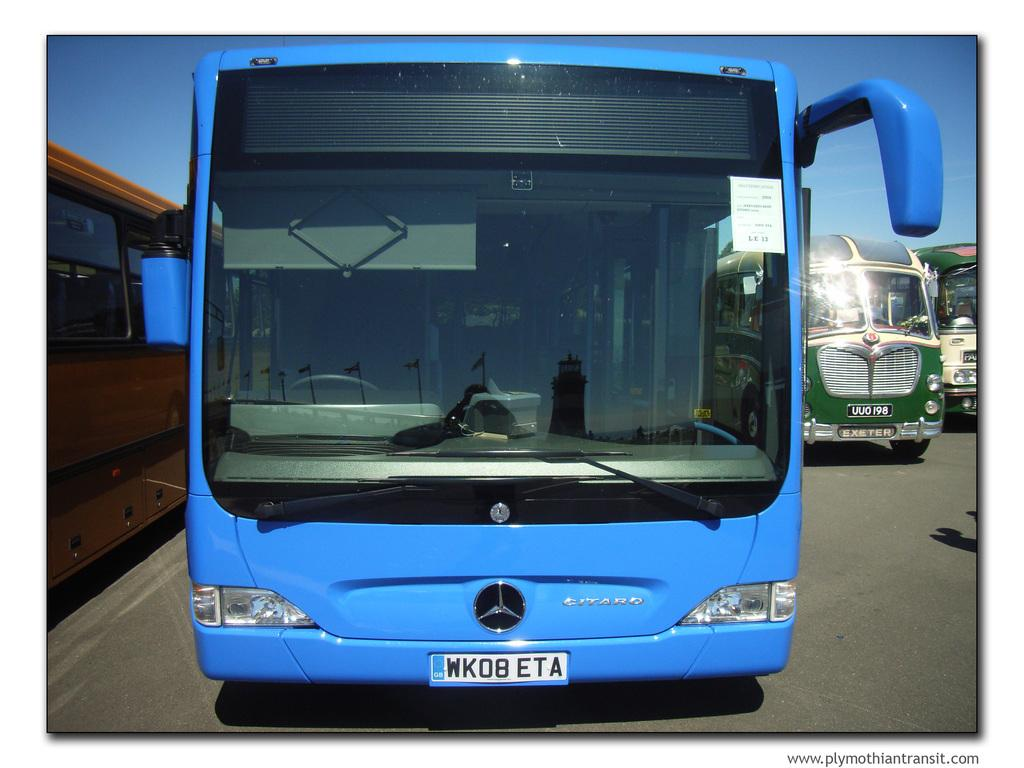<image>
Create a compact narrative representing the image presented. A blue bus has the licence plate WK08 ETA. 